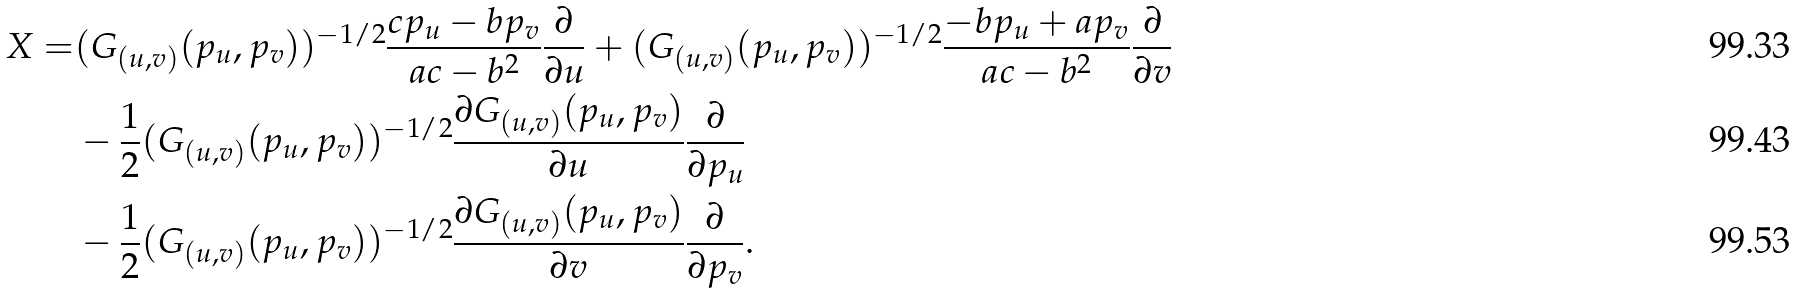<formula> <loc_0><loc_0><loc_500><loc_500>X = & ( G _ { ( u , v ) } ( p _ { u } , p _ { v } ) ) ^ { - 1 / 2 } \frac { c p _ { u } - b p _ { v } } { a c - b ^ { 2 } } \frac { \partial } { \partial u } + ( G _ { ( u , v ) } ( p _ { u } , p _ { v } ) ) ^ { - 1 / 2 } \frac { - b p _ { u } + a p _ { v } } { a c - b ^ { 2 } } \frac { \partial } { \partial v } \\ & - \frac { 1 } { 2 } ( G _ { ( u , v ) } ( p _ { u } , p _ { v } ) ) ^ { - 1 / 2 } \frac { \partial G _ { ( u , v ) } ( p _ { u } , p _ { v } ) } { \partial u } \frac { \partial } { \partial p _ { u } } \\ & - \frac { 1 } { 2 } ( G _ { ( u , v ) } ( p _ { u } , p _ { v } ) ) ^ { - 1 / 2 } \frac { \partial G _ { ( u , v ) } ( p _ { u } , p _ { v } ) } { \partial v } \frac { \partial } { \partial p _ { v } } .</formula> 